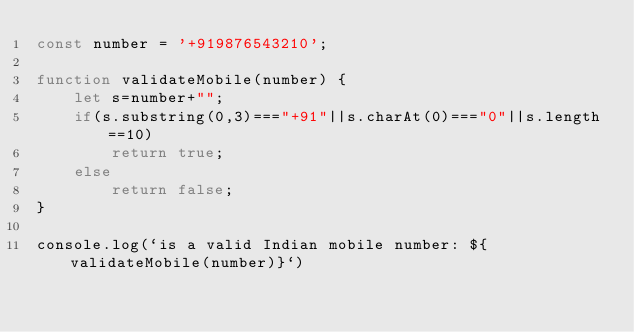Convert code to text. <code><loc_0><loc_0><loc_500><loc_500><_JavaScript_>const number = '+919876543210';

function validateMobile(number) {
    let s=number+"";
    if(s.substring(0,3)==="+91"||s.charAt(0)==="0"||s.length==10)
        return true;
    else
        return false;
}

console.log(`is a valid Indian mobile number: ${validateMobile(number)}`)
</code> 